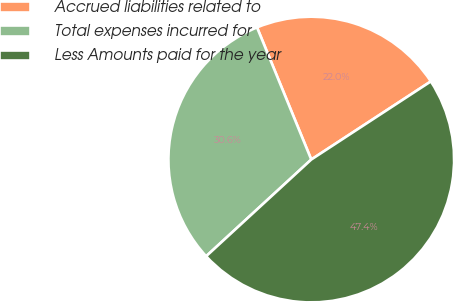Convert chart. <chart><loc_0><loc_0><loc_500><loc_500><pie_chart><fcel>Accrued liabilities related to<fcel>Total expenses incurred for<fcel>Less Amounts paid for the year<nl><fcel>21.99%<fcel>30.64%<fcel>47.38%<nl></chart> 